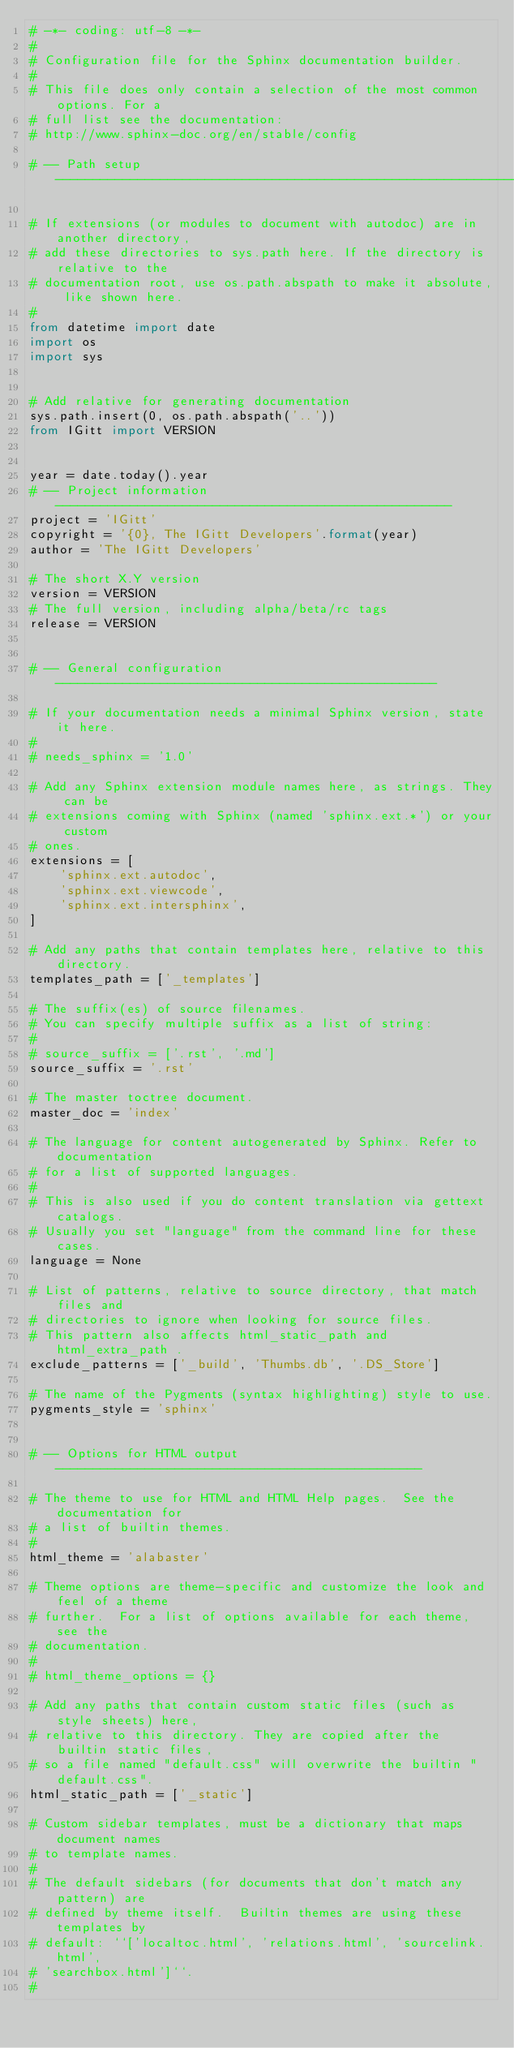Convert code to text. <code><loc_0><loc_0><loc_500><loc_500><_Python_># -*- coding: utf-8 -*-
#
# Configuration file for the Sphinx documentation builder.
#
# This file does only contain a selection of the most common options. For a
# full list see the documentation:
# http://www.sphinx-doc.org/en/stable/config

# -- Path setup --------------------------------------------------------------

# If extensions (or modules to document with autodoc) are in another directory,
# add these directories to sys.path here. If the directory is relative to the
# documentation root, use os.path.abspath to make it absolute, like shown here.
#
from datetime import date
import os
import sys


# Add relative for generating documentation
sys.path.insert(0, os.path.abspath('..'))
from IGitt import VERSION


year = date.today().year
# -- Project information -----------------------------------------------------
project = 'IGitt'
copyright = '{0}, The IGitt Developers'.format(year)
author = 'The IGitt Developers'

# The short X.Y version
version = VERSION
# The full version, including alpha/beta/rc tags
release = VERSION


# -- General configuration ---------------------------------------------------

# If your documentation needs a minimal Sphinx version, state it here.
#
# needs_sphinx = '1.0'

# Add any Sphinx extension module names here, as strings. They can be
# extensions coming with Sphinx (named 'sphinx.ext.*') or your custom
# ones.
extensions = [
    'sphinx.ext.autodoc',
    'sphinx.ext.viewcode',
    'sphinx.ext.intersphinx',
]

# Add any paths that contain templates here, relative to this directory.
templates_path = ['_templates']

# The suffix(es) of source filenames.
# You can specify multiple suffix as a list of string:
#
# source_suffix = ['.rst', '.md']
source_suffix = '.rst'

# The master toctree document.
master_doc = 'index'

# The language for content autogenerated by Sphinx. Refer to documentation
# for a list of supported languages.
#
# This is also used if you do content translation via gettext catalogs.
# Usually you set "language" from the command line for these cases.
language = None

# List of patterns, relative to source directory, that match files and
# directories to ignore when looking for source files.
# This pattern also affects html_static_path and html_extra_path .
exclude_patterns = ['_build', 'Thumbs.db', '.DS_Store']

# The name of the Pygments (syntax highlighting) style to use.
pygments_style = 'sphinx'


# -- Options for HTML output -------------------------------------------------

# The theme to use for HTML and HTML Help pages.  See the documentation for
# a list of builtin themes.
#
html_theme = 'alabaster'

# Theme options are theme-specific and customize the look and feel of a theme
# further.  For a list of options available for each theme, see the
# documentation.
#
# html_theme_options = {}

# Add any paths that contain custom static files (such as style sheets) here,
# relative to this directory. They are copied after the builtin static files,
# so a file named "default.css" will overwrite the builtin "default.css".
html_static_path = ['_static']

# Custom sidebar templates, must be a dictionary that maps document names
# to template names.
#
# The default sidebars (for documents that don't match any pattern) are
# defined by theme itself.  Builtin themes are using these templates by
# default: ``['localtoc.html', 'relations.html', 'sourcelink.html',
# 'searchbox.html']``.
#</code> 